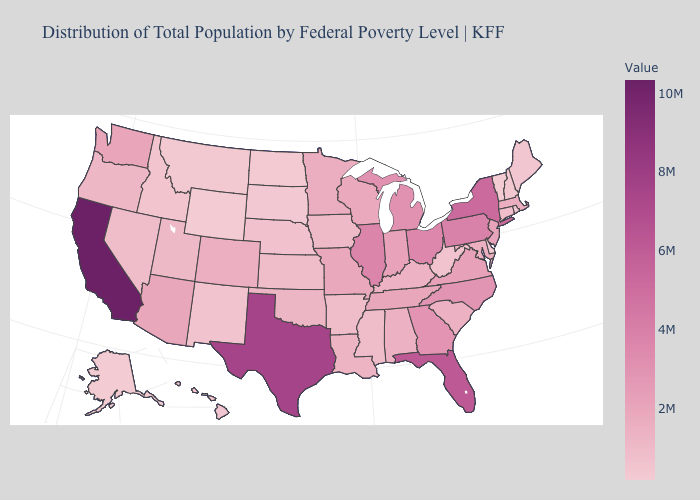Which states have the highest value in the USA?
Answer briefly. California. Which states have the lowest value in the West?
Concise answer only. Wyoming. Does New York have the highest value in the Northeast?
Quick response, please. Yes. 